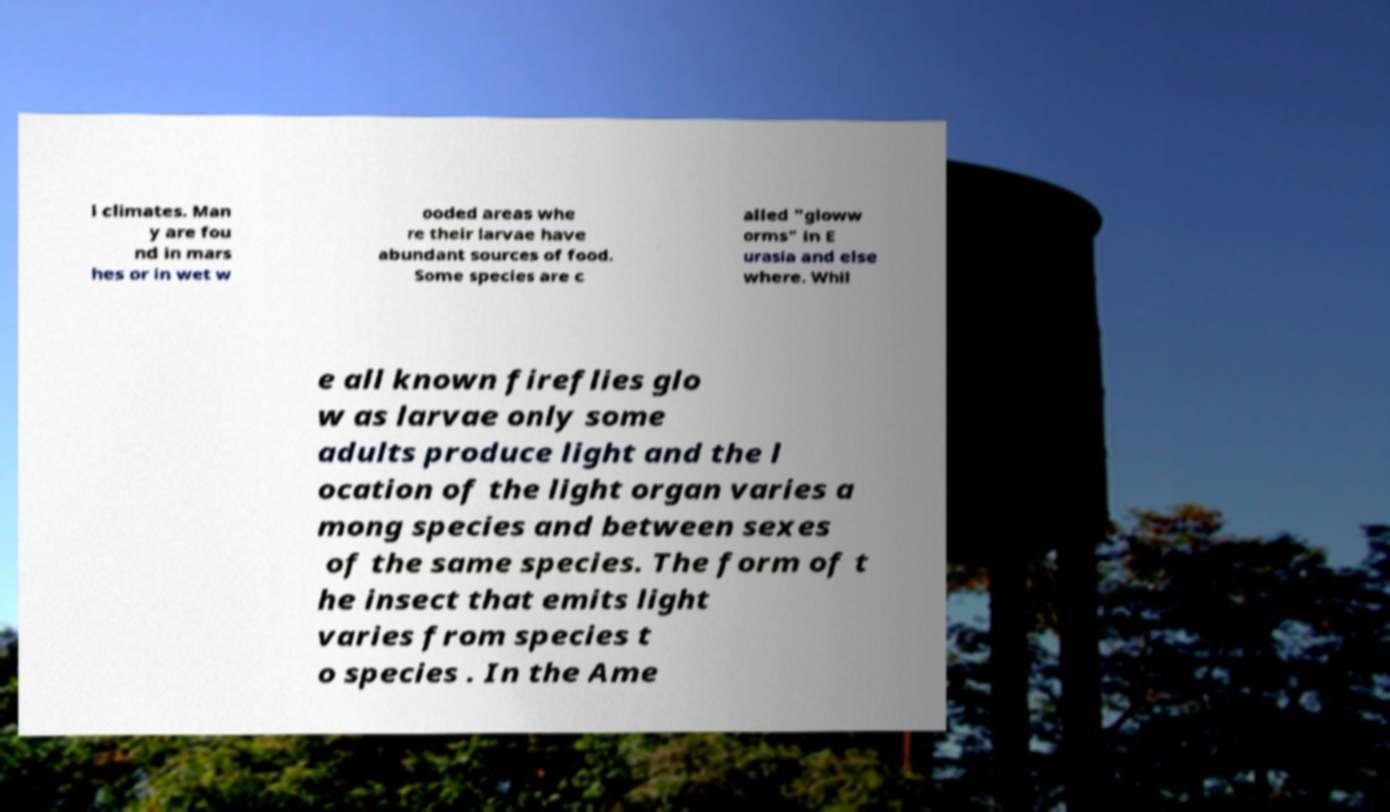What messages or text are displayed in this image? I need them in a readable, typed format. l climates. Man y are fou nd in mars hes or in wet w ooded areas whe re their larvae have abundant sources of food. Some species are c alled "gloww orms" in E urasia and else where. Whil e all known fireflies glo w as larvae only some adults produce light and the l ocation of the light organ varies a mong species and between sexes of the same species. The form of t he insect that emits light varies from species t o species . In the Ame 